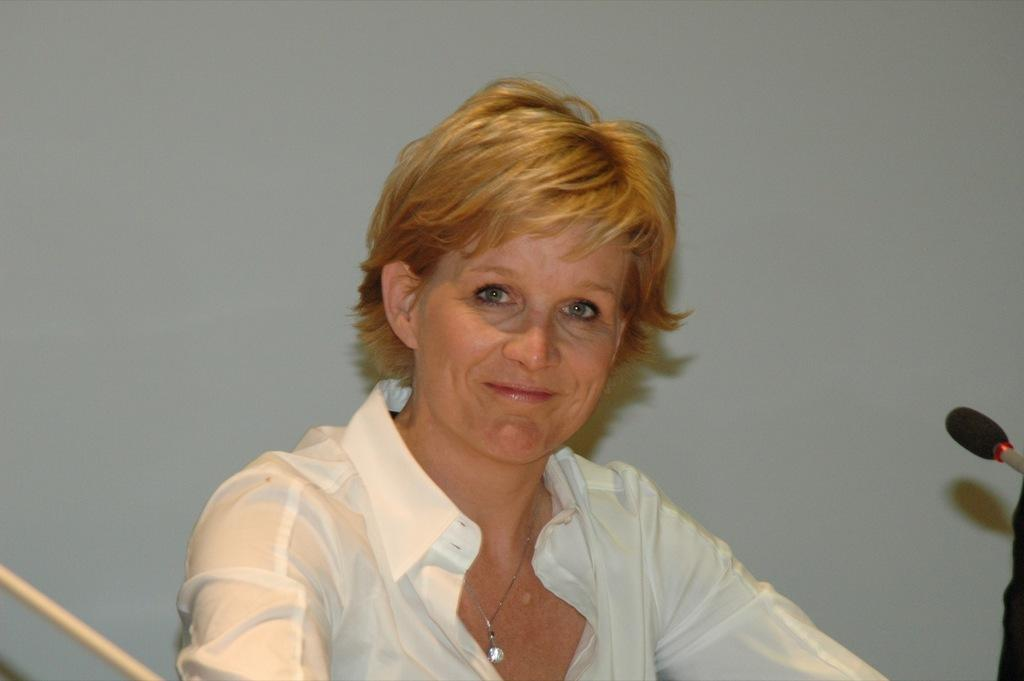Who is present in the image? There is a woman in the image. What can be seen in the background of the image? There is a wall in the background of the image. What color is the girl's hair in the image? There is no girl present in the image, only a woman. Additionally, the image does not show any hair, so we cannot determine its color. 